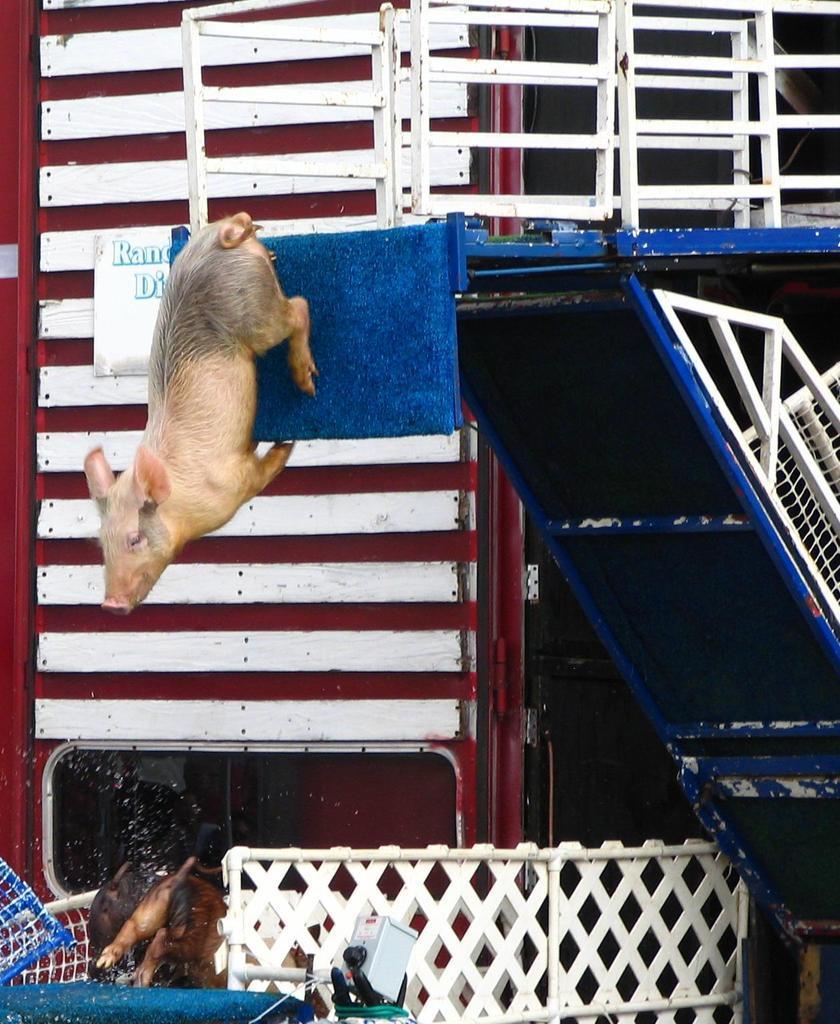In one or two sentences, can you explain what this image depicts? In this image we can see a pig, there are railings, there is a board on the wall, with text on it, there is an animal in the basket, also we can see the stand. 